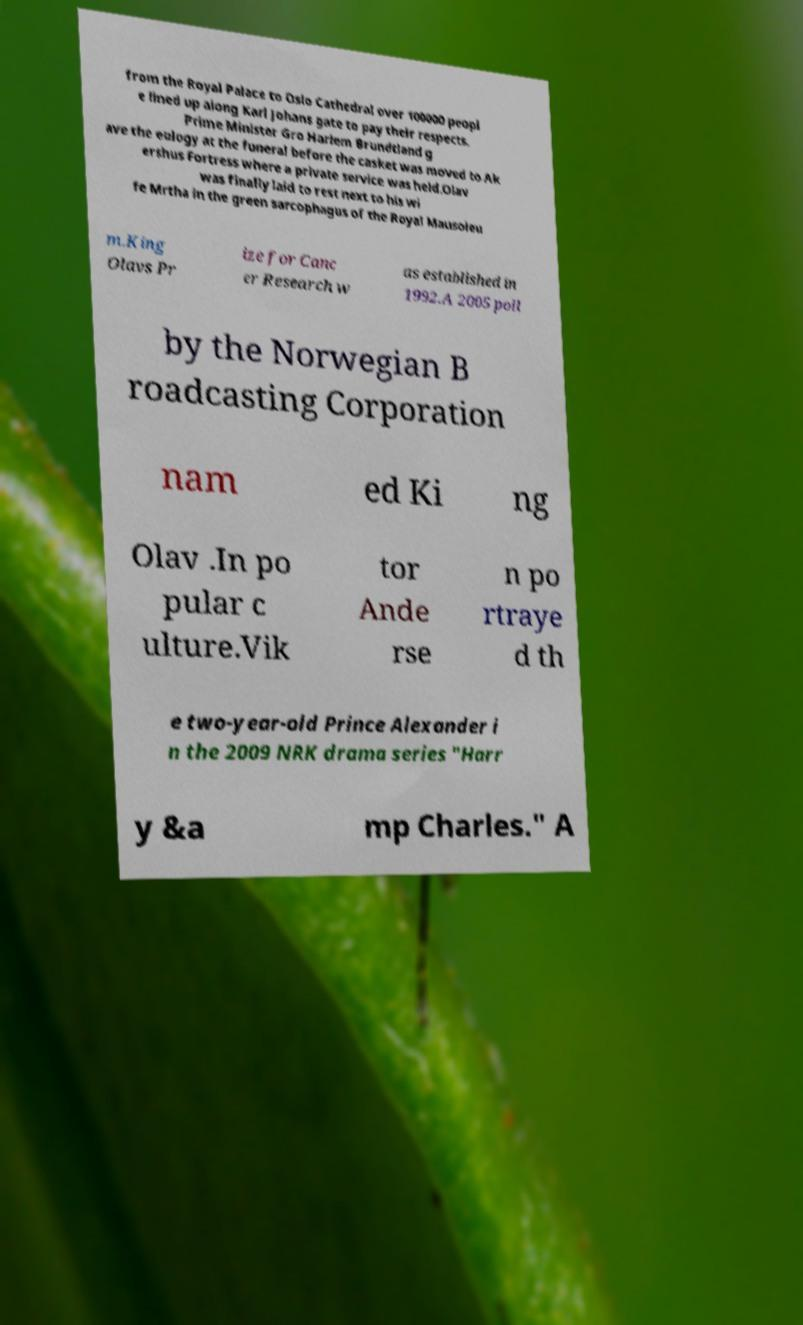Can you accurately transcribe the text from the provided image for me? from the Royal Palace to Oslo Cathedral over 100000 peopl e lined up along Karl Johans gate to pay their respects. Prime Minister Gro Harlem Brundtland g ave the eulogy at the funeral before the casket was moved to Ak ershus Fortress where a private service was held.Olav was finally laid to rest next to his wi fe Mrtha in the green sarcophagus of the Royal Mausoleu m.King Olavs Pr ize for Canc er Research w as established in 1992.A 2005 poll by the Norwegian B roadcasting Corporation nam ed Ki ng Olav .In po pular c ulture.Vik tor Ande rse n po rtraye d th e two-year-old Prince Alexander i n the 2009 NRK drama series "Harr y &a mp Charles." A 